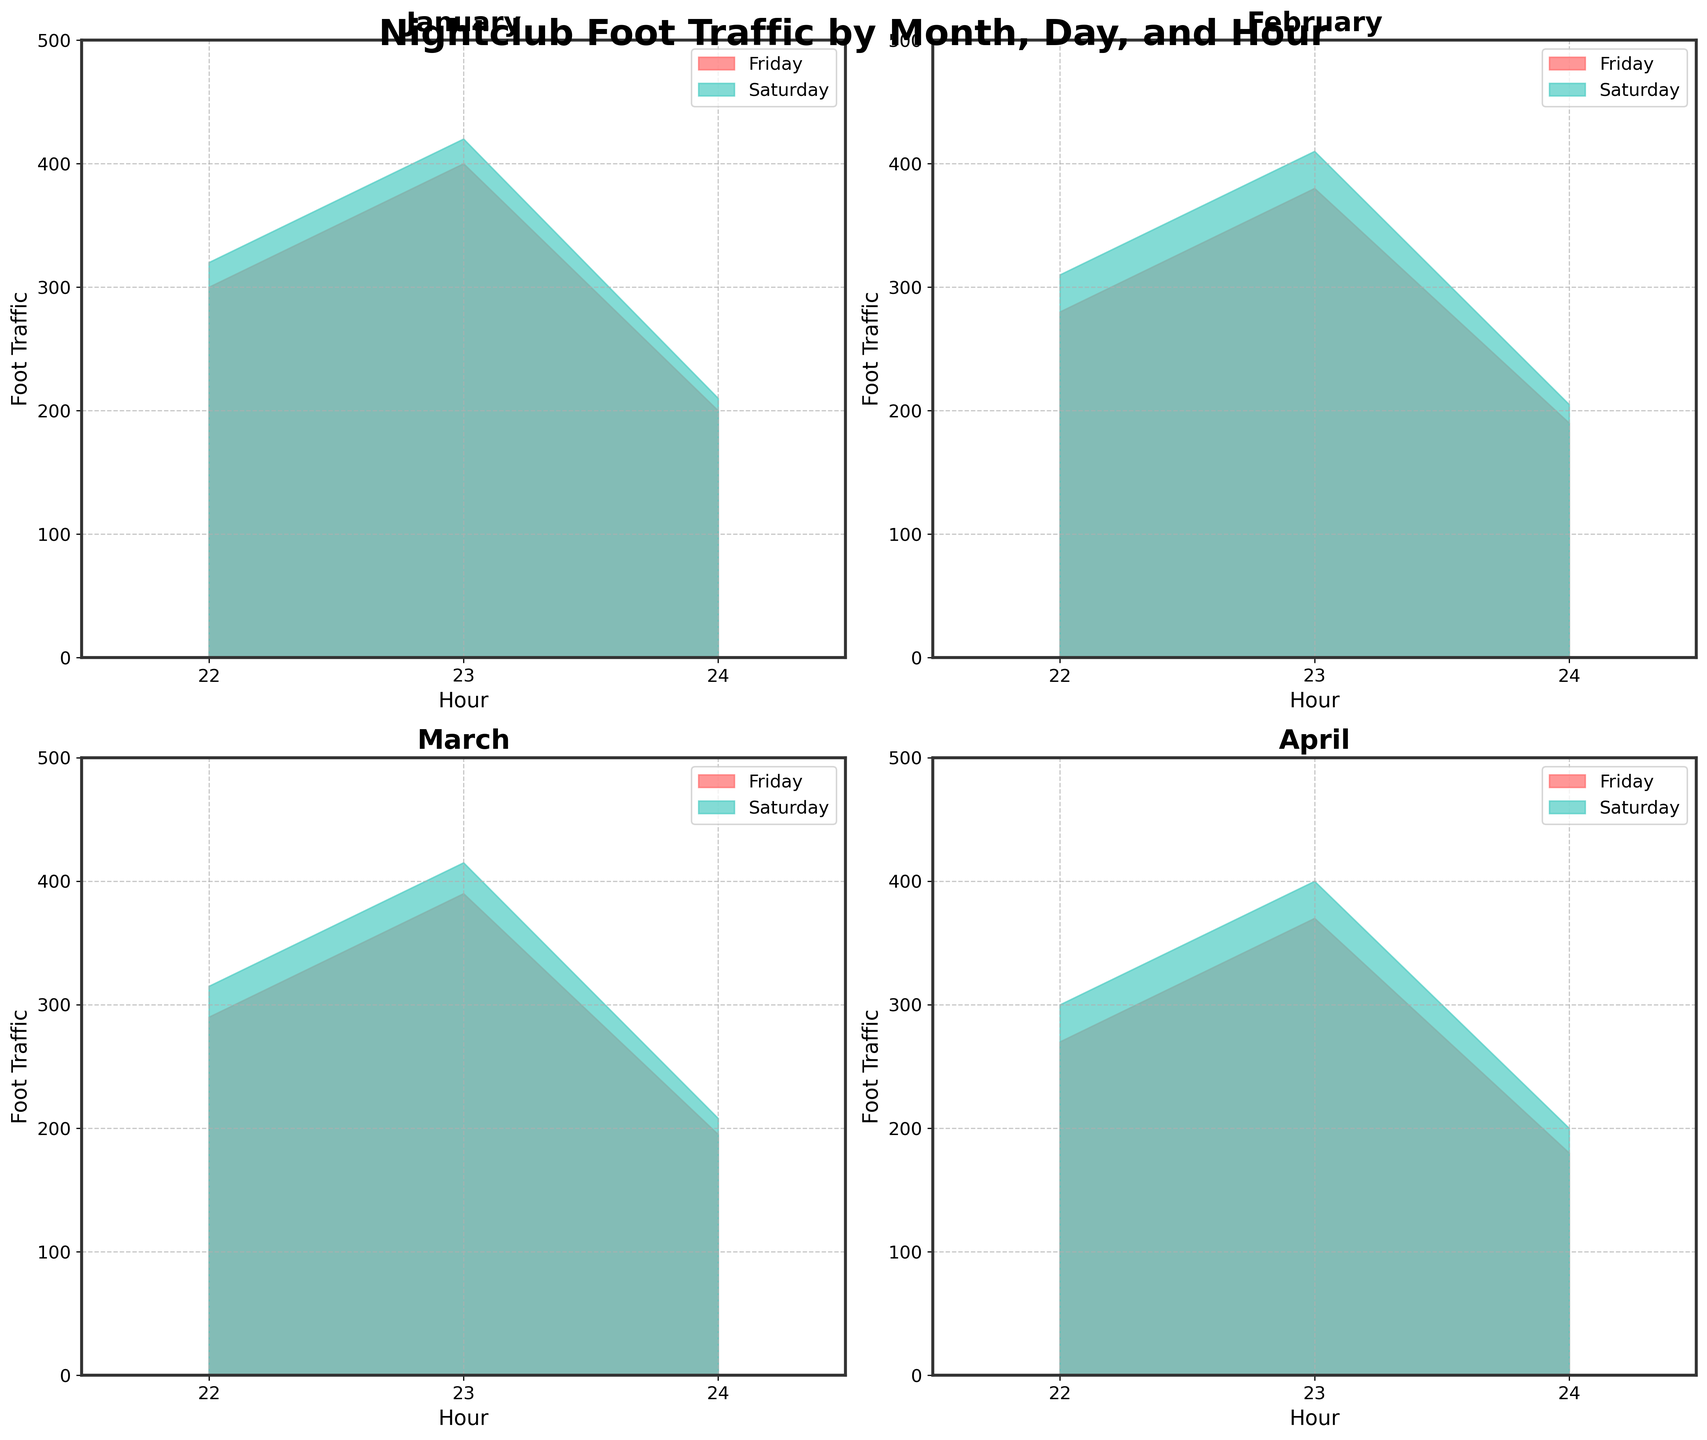How does the foot traffic on Fridays in January at 22:00 compare to that at 23:00? On the plot for January, look at the area under the Friday curve at 22:00 and 23:00. At 22:00, the foot traffic is 300, and at 23:00, it increases to 400.
Answer: The foot traffic at 23:00 is higher than at 22:00 Which month has the highest peak hour foot traffic on Saturdays? Examine the peak values on Saturdays for each month. In January, the peak (23:00) is 420; in February, it's 410; in March, it's 415; and in April, it's 400. January has the highest peak.
Answer: January What is the average foot traffic at midnight across all months for Fridays? For Fridays at midnight (Hour 24), the values are January 200, February 190, March 195, and April 180. The average is (200 + 190 + 195 + 180) / 4 = 191.25.
Answer: 191.25 Which day of the week generally has more foot traffic in February? Compare the areas under the curves for both Friday and Saturday in February. Both days have their peaks at 23:00, with Friday reaching 380 and Saturday reaching 410.
Answer: Saturday Is there any month where the foot traffic dips below 200 for both days of the week? Look at each month's subplots. In April, both Friday and Saturday have points where the foot traffic is below 200 (Fridays at 24:00 with 180, and Saturdays at 24:00 with 200).
Answer: Yes, in April How does the foot traffic trend differ between January and April? Compare the subplots for January and April. Generally, both start high at 22:00, peak around 23:00, and dip at 24:00. However, January has higher overall values, with more pronounced peaks.
Answer: January has higher foot traffic overall Does the foot traffic in March drop more sharply after peak hour compared to January? Observe the slopes after the peak hours (23:00). In January, the foot traffic drops from 400 to 200 for Fridays and 420 to 210 for Saturdays. In March, it drops from 390 to 195 for Fridays and 415 to 208 for Saturdays.
Answer: No, the drop is similar What is the range of foot traffic on Saturdays in March from 22:00 to 24:00? For March Saturdays, foot traffic ranges from a minimum of 208 at 24:00 to a maximum of 415 at 23:00.
Answer: 208 - 415 In which hour do both Friday and Saturday have the same foot traffic through all months? Look over each hour (22:00, 23:00, 24:00) across all months. There isn’t a single hour where both days’ foot traffic matches exactly in any month.
Answer: None 